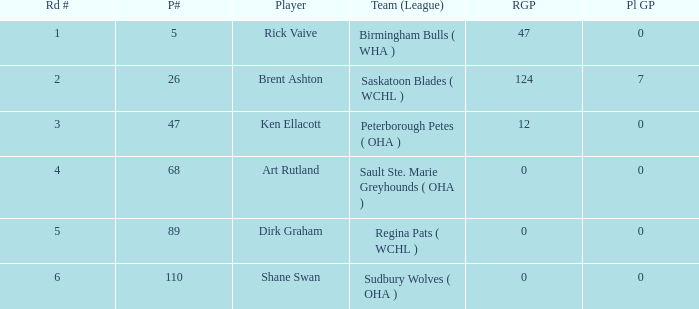How many reg GP for rick vaive in round 1? None. 